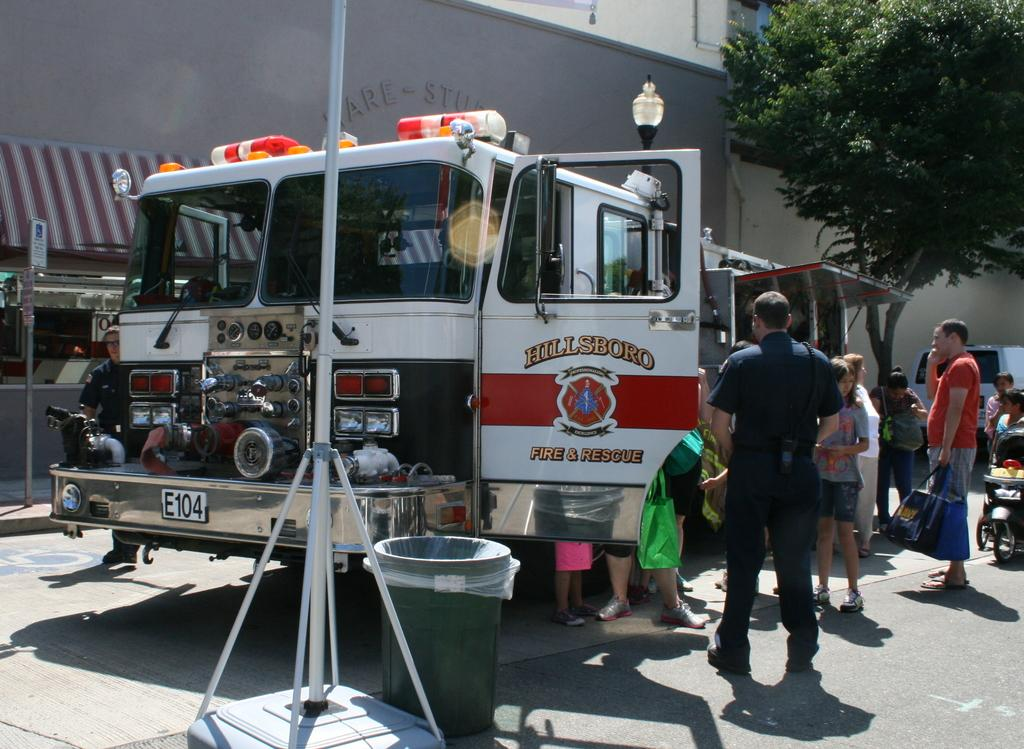What is the main subject in the center of the image? There is a vehicle in the center of the image. What else can be seen in the center of the image? There are persons on the road in the center of the image. What can be seen in the background of the image? There is a tree, buildings, a light, and another vehicle in the background of the image. What type of heart can be seen beating in the image? There is no heart visible in the image. What season is depicted in the image? The image does not depict a specific season, as there are no seasonal indicators present. 